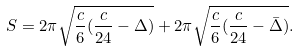Convert formula to latex. <formula><loc_0><loc_0><loc_500><loc_500>S = 2 \pi \sqrt { \frac { c } { 6 } ( \frac { c } { 2 4 } - \Delta ) } + 2 \pi \sqrt { \frac { c } { 6 } ( \frac { c } { 2 4 } - \bar { \Delta } ) } .</formula> 